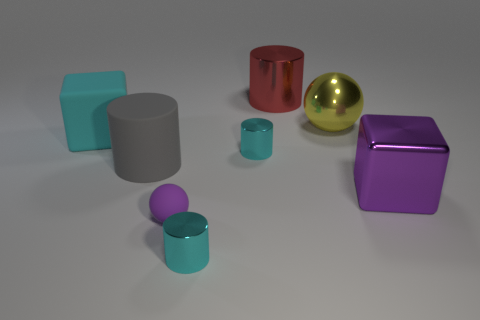What number of other objects are the same shape as the small rubber object?
Give a very brief answer. 1. There is a matte cylinder; does it have the same color as the big metal thing in front of the big yellow metallic sphere?
Your answer should be very brief. No. Are there any other things that have the same material as the large yellow sphere?
Provide a short and direct response. Yes. What shape is the large object that is right of the sphere on the right side of the big red cylinder?
Your answer should be very brief. Cube. The shiny object that is the same color as the tiny matte sphere is what size?
Offer a terse response. Large. Do the thing behind the large yellow shiny sphere and the purple matte thing have the same shape?
Give a very brief answer. No. Are there more cyan things behind the big yellow shiny thing than large spheres in front of the large purple metallic thing?
Your answer should be very brief. No. What number of small metal cylinders are right of the matte object that is on the right side of the gray thing?
Ensure brevity in your answer.  2. There is a big block that is the same color as the tiny rubber thing; what is its material?
Keep it short and to the point. Metal. How many other things are the same color as the large metal block?
Give a very brief answer. 1. 